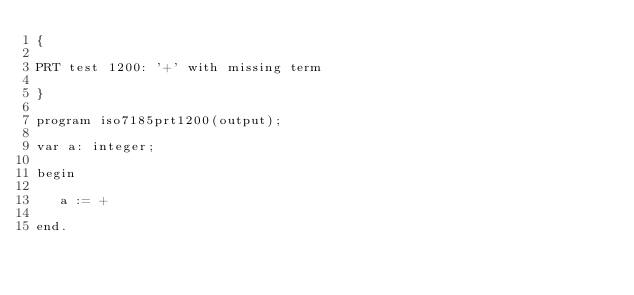<code> <loc_0><loc_0><loc_500><loc_500><_Pascal_>{

PRT test 1200: '+' with missing term

}

program iso7185prt1200(output);

var a: integer;

begin

   a := +  

end.
</code> 